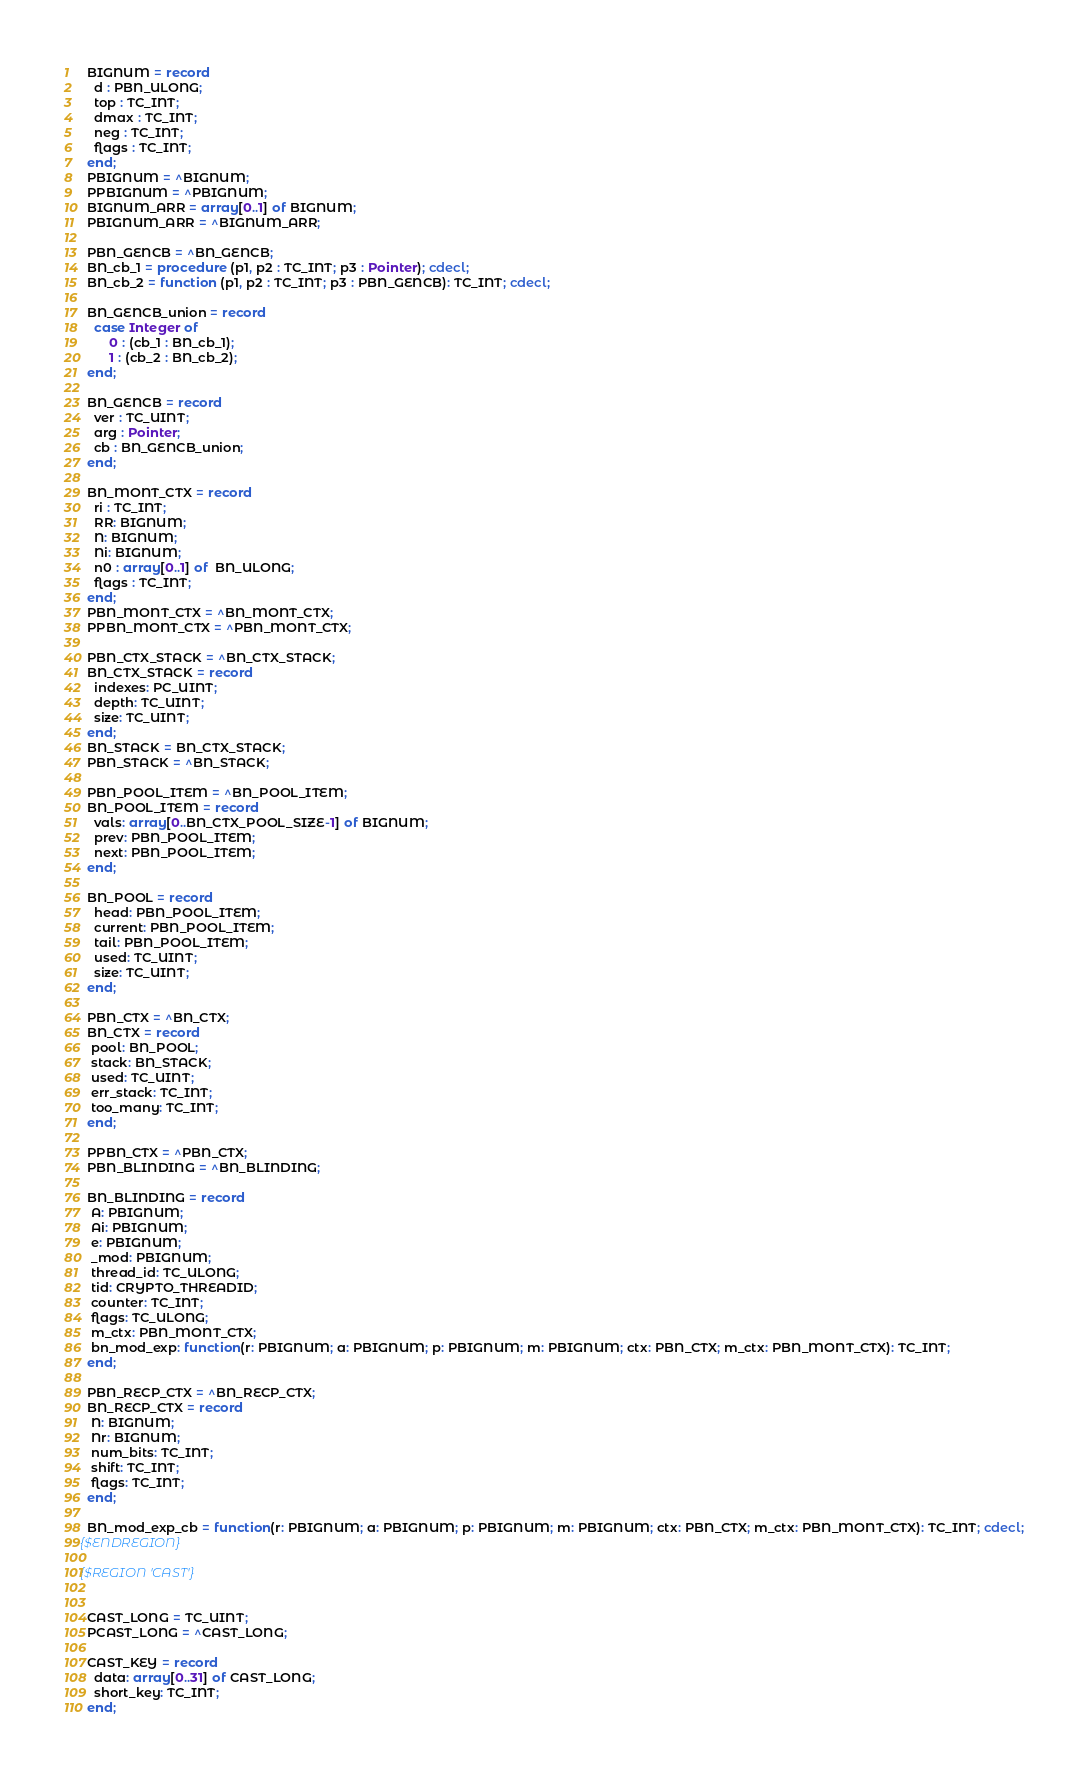Convert code to text. <code><loc_0><loc_0><loc_500><loc_500><_Pascal_>  BIGNUM = record
    d : PBN_ULONG;
    top : TC_INT;
    dmax : TC_INT;
    neg : TC_INT;
    flags : TC_INT;
  end;
  PBIGNUM = ^BIGNUM;
  PPBIGNUM = ^PBIGNUM;
  BIGNUM_ARR = array[0..1] of BIGNUM;
  PBIGNUM_ARR = ^BIGNUM_ARR;

  PBN_GENCB = ^BN_GENCB;
  BN_cb_1 = procedure (p1, p2 : TC_INT; p3 : Pointer); cdecl;
  BN_cb_2 = function (p1, p2 : TC_INT; p3 : PBN_GENCB): TC_INT; cdecl;

  BN_GENCB_union = record
    case Integer of
        0 : (cb_1 : BN_cb_1);
        1 : (cb_2 : BN_cb_2);
  end;

  BN_GENCB = record
    ver : TC_UINT;
    arg : Pointer;
    cb : BN_GENCB_union;
  end;

  BN_MONT_CTX = record
    ri : TC_INT;
    RR: BIGNUM;
    N: BIGNUM;
    Ni: BIGNUM;
    n0 : array[0..1] of  BN_ULONG;
    flags : TC_INT;
  end;
  PBN_MONT_CTX = ^BN_MONT_CTX;
  PPBN_MONT_CTX = ^PBN_MONT_CTX;

  PBN_CTX_STACK = ^BN_CTX_STACK;
  BN_CTX_STACK = record
    indexes: PC_UINT;
    depth: TC_UINT;
    size: TC_UINT;
  end;
  BN_STACK = BN_CTX_STACK;
  PBN_STACK = ^BN_STACK;

  PBN_POOL_ITEM = ^BN_POOL_ITEM;
  BN_POOL_ITEM = record
    vals: array[0..BN_CTX_POOL_SIZE-1] of BIGNUM;
    prev: PBN_POOL_ITEM;
    next: PBN_POOL_ITEM;
  end;

  BN_POOL = record
    head: PBN_POOL_ITEM;
    current: PBN_POOL_ITEM;
    tail: PBN_POOL_ITEM;
    used: TC_UINT;
    size: TC_UINT;
  end;

  PBN_CTX = ^BN_CTX;
  BN_CTX = record
   pool: BN_POOL;
   stack: BN_STACK;
   used: TC_UINT;
   err_stack: TC_INT;
   too_many: TC_INT;
  end;

  PPBN_CTX = ^PBN_CTX;
  PBN_BLINDING = ^BN_BLINDING;

  BN_BLINDING = record
   A: PBIGNUM;
   Ai: PBIGNUM;
   e: PBIGNUM;
   _mod: PBIGNUM;
   thread_id: TC_ULONG;
   tid: CRYPTO_THREADID;
   counter: TC_INT;
   flags: TC_ULONG;
   m_ctx: PBN_MONT_CTX;
   bn_mod_exp: function(r: PBIGNUM; a: PBIGNUM; p: PBIGNUM; m: PBIGNUM; ctx: PBN_CTX; m_ctx: PBN_MONT_CTX): TC_INT;
  end;

  PBN_RECP_CTX = ^BN_RECP_CTX;
  BN_RECP_CTX = record
   N: BIGNUM;
   Nr: BIGNUM;
   num_bits: TC_INT;
   shift: TC_INT;
   flags: TC_INT;
  end;

  BN_mod_exp_cb = function(r: PBIGNUM; a: PBIGNUM; p: PBIGNUM; m: PBIGNUM; ctx: PBN_CTX; m_ctx: PBN_MONT_CTX): TC_INT; cdecl;
{$ENDREGION}

{$REGION 'CAST'}


  CAST_LONG = TC_UINT;
  PCAST_LONG = ^CAST_LONG;

  CAST_KEY = record
    data: array[0..31] of CAST_LONG;
    short_key: TC_INT;
  end;</code> 